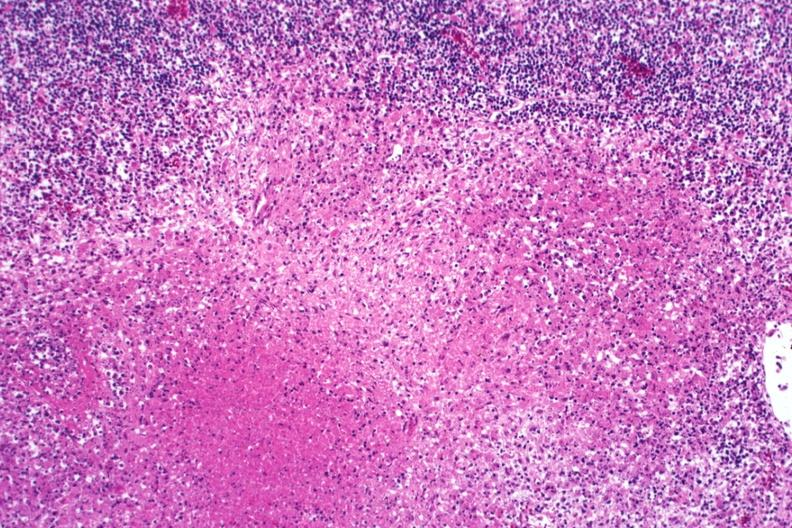what is present?
Answer the question using a single word or phrase. Lymph node 